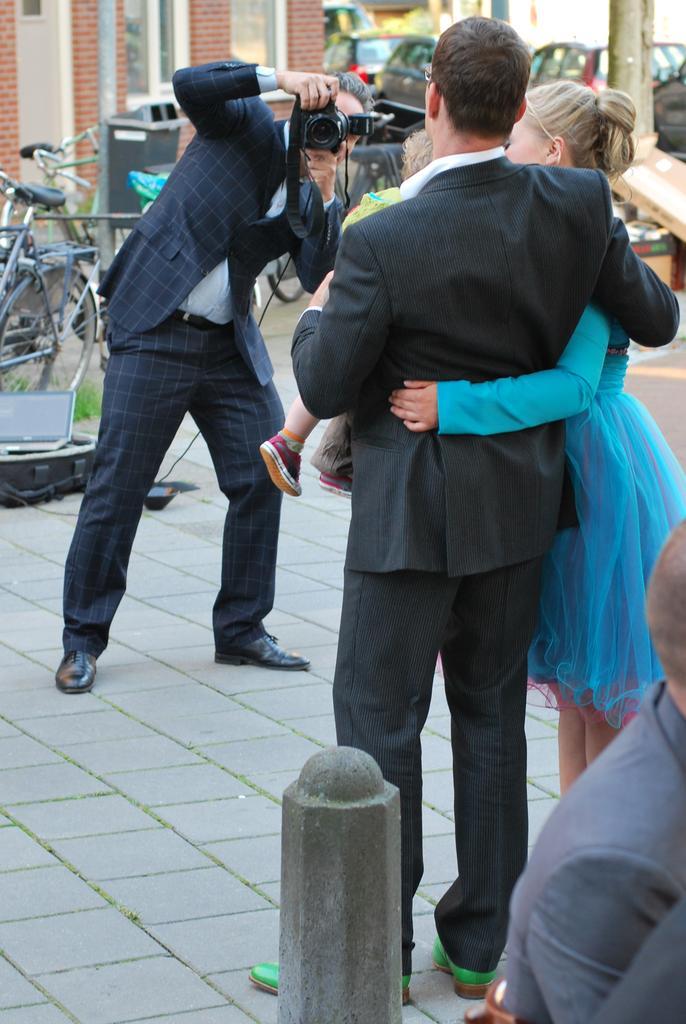How would you summarize this image in a sentence or two? In the image in the center, we can see two persons are standing and one person standing and holding the camera. In the bottom of the image, we can see one pole and one person sitting. In the background there is a building, wall, vehicles, poles etc. 